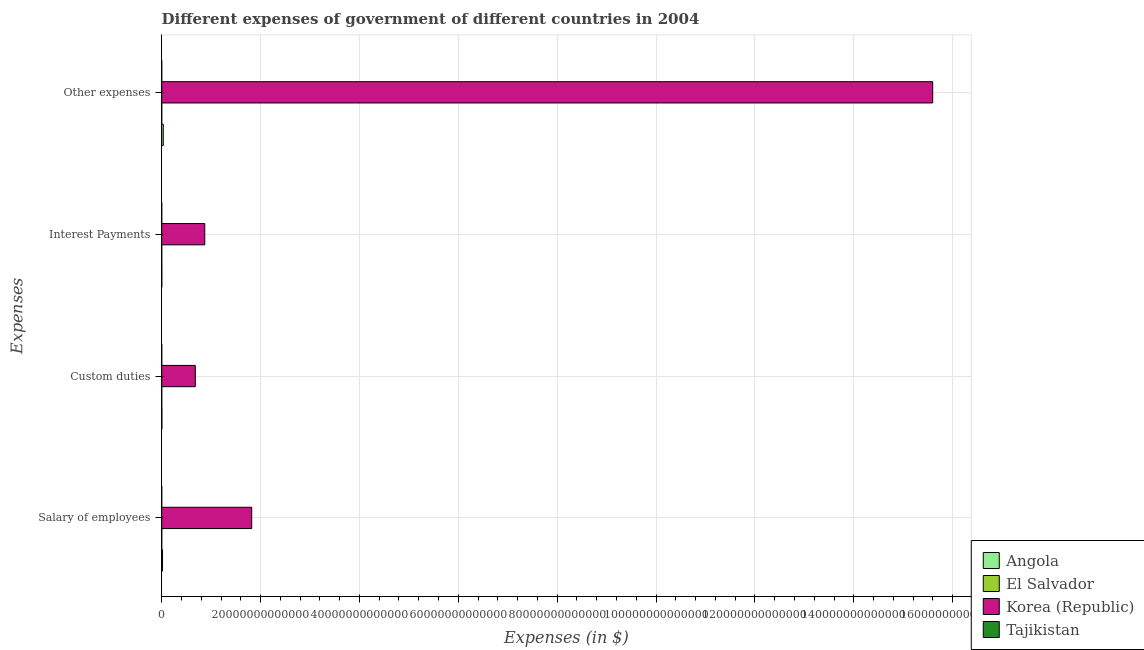How many groups of bars are there?
Keep it short and to the point. 4. Are the number of bars per tick equal to the number of legend labels?
Provide a short and direct response. Yes. How many bars are there on the 3rd tick from the bottom?
Offer a terse response. 4. What is the label of the 3rd group of bars from the top?
Offer a terse response. Custom duties. What is the amount spent on custom duties in Tajikistan?
Give a very brief answer. 9.66e+07. Across all countries, what is the maximum amount spent on salary of employees?
Your answer should be compact. 1.82e+13. Across all countries, what is the minimum amount spent on custom duties?
Make the answer very short. 9.66e+07. In which country was the amount spent on other expenses maximum?
Your response must be concise. Korea (Republic). In which country was the amount spent on custom duties minimum?
Keep it short and to the point. Tajikistan. What is the total amount spent on other expenses in the graph?
Keep it short and to the point. 1.56e+14. What is the difference between the amount spent on salary of employees in El Salvador and that in Korea (Republic)?
Provide a succinct answer. -1.82e+13. What is the difference between the amount spent on custom duties in Tajikistan and the amount spent on interest payments in Korea (Republic)?
Provide a short and direct response. -8.71e+12. What is the average amount spent on other expenses per country?
Offer a terse response. 3.91e+13. What is the difference between the amount spent on salary of employees and amount spent on interest payments in El Salvador?
Offer a terse response. 7.58e+08. What is the ratio of the amount spent on salary of employees in Tajikistan to that in Angola?
Ensure brevity in your answer.  0. Is the difference between the amount spent on interest payments in Angola and Korea (Republic) greater than the difference between the amount spent on salary of employees in Angola and Korea (Republic)?
Your answer should be compact. Yes. What is the difference between the highest and the second highest amount spent on salary of employees?
Provide a short and direct response. 1.80e+13. What is the difference between the highest and the lowest amount spent on salary of employees?
Give a very brief answer. 1.82e+13. Is it the case that in every country, the sum of the amount spent on interest payments and amount spent on custom duties is greater than the sum of amount spent on other expenses and amount spent on salary of employees?
Provide a succinct answer. No. What does the 3rd bar from the top in Interest Payments represents?
Make the answer very short. El Salvador. What does the 1st bar from the bottom in Salary of employees represents?
Your answer should be very brief. Angola. Are all the bars in the graph horizontal?
Give a very brief answer. Yes. What is the difference between two consecutive major ticks on the X-axis?
Your answer should be compact. 2.00e+13. Does the graph contain grids?
Offer a very short reply. Yes. Where does the legend appear in the graph?
Make the answer very short. Bottom right. How many legend labels are there?
Make the answer very short. 4. What is the title of the graph?
Ensure brevity in your answer.  Different expenses of government of different countries in 2004. What is the label or title of the X-axis?
Ensure brevity in your answer.  Expenses (in $). What is the label or title of the Y-axis?
Provide a succinct answer. Expenses. What is the Expenses (in $) in Angola in Salary of employees?
Ensure brevity in your answer.  1.67e+11. What is the Expenses (in $) in El Salvador in Salary of employees?
Provide a succinct answer. 1.12e+09. What is the Expenses (in $) of Korea (Republic) in Salary of employees?
Your answer should be very brief. 1.82e+13. What is the Expenses (in $) in Tajikistan in Salary of employees?
Keep it short and to the point. 7.91e+07. What is the Expenses (in $) in Angola in Custom duties?
Offer a very short reply. 2.48e+1. What is the Expenses (in $) in El Salvador in Custom duties?
Provide a succinct answer. 1.74e+08. What is the Expenses (in $) of Korea (Republic) in Custom duties?
Make the answer very short. 6.80e+12. What is the Expenses (in $) of Tajikistan in Custom duties?
Your answer should be compact. 9.66e+07. What is the Expenses (in $) in Angola in Interest Payments?
Provide a succinct answer. 1.78e+1. What is the Expenses (in $) in El Salvador in Interest Payments?
Give a very brief answer. 3.60e+08. What is the Expenses (in $) in Korea (Republic) in Interest Payments?
Your response must be concise. 8.71e+12. What is the Expenses (in $) of Tajikistan in Interest Payments?
Keep it short and to the point. 4.43e+07. What is the Expenses (in $) of Angola in Other expenses?
Provide a short and direct response. 3.18e+11. What is the Expenses (in $) of El Salvador in Other expenses?
Keep it short and to the point. 2.69e+09. What is the Expenses (in $) in Korea (Republic) in Other expenses?
Your response must be concise. 1.56e+14. What is the Expenses (in $) in Tajikistan in Other expenses?
Your response must be concise. 8.48e+08. Across all Expenses, what is the maximum Expenses (in $) in Angola?
Make the answer very short. 3.18e+11. Across all Expenses, what is the maximum Expenses (in $) of El Salvador?
Make the answer very short. 2.69e+09. Across all Expenses, what is the maximum Expenses (in $) of Korea (Republic)?
Your answer should be very brief. 1.56e+14. Across all Expenses, what is the maximum Expenses (in $) of Tajikistan?
Provide a succinct answer. 8.48e+08. Across all Expenses, what is the minimum Expenses (in $) of Angola?
Your response must be concise. 1.78e+1. Across all Expenses, what is the minimum Expenses (in $) of El Salvador?
Keep it short and to the point. 1.74e+08. Across all Expenses, what is the minimum Expenses (in $) in Korea (Republic)?
Keep it short and to the point. 6.80e+12. Across all Expenses, what is the minimum Expenses (in $) of Tajikistan?
Offer a terse response. 4.43e+07. What is the total Expenses (in $) in Angola in the graph?
Your answer should be compact. 5.27e+11. What is the total Expenses (in $) in El Salvador in the graph?
Offer a very short reply. 4.35e+09. What is the total Expenses (in $) of Korea (Republic) in the graph?
Your answer should be very brief. 1.90e+14. What is the total Expenses (in $) in Tajikistan in the graph?
Offer a very short reply. 1.07e+09. What is the difference between the Expenses (in $) of Angola in Salary of employees and that in Custom duties?
Provide a short and direct response. 1.42e+11. What is the difference between the Expenses (in $) of El Salvador in Salary of employees and that in Custom duties?
Give a very brief answer. 9.44e+08. What is the difference between the Expenses (in $) in Korea (Republic) in Salary of employees and that in Custom duties?
Offer a terse response. 1.14e+13. What is the difference between the Expenses (in $) in Tajikistan in Salary of employees and that in Custom duties?
Provide a short and direct response. -1.75e+07. What is the difference between the Expenses (in $) in Angola in Salary of employees and that in Interest Payments?
Keep it short and to the point. 1.49e+11. What is the difference between the Expenses (in $) of El Salvador in Salary of employees and that in Interest Payments?
Give a very brief answer. 7.58e+08. What is the difference between the Expenses (in $) of Korea (Republic) in Salary of employees and that in Interest Payments?
Your answer should be compact. 9.50e+12. What is the difference between the Expenses (in $) in Tajikistan in Salary of employees and that in Interest Payments?
Keep it short and to the point. 3.48e+07. What is the difference between the Expenses (in $) in Angola in Salary of employees and that in Other expenses?
Give a very brief answer. -1.51e+11. What is the difference between the Expenses (in $) in El Salvador in Salary of employees and that in Other expenses?
Provide a short and direct response. -1.57e+09. What is the difference between the Expenses (in $) in Korea (Republic) in Salary of employees and that in Other expenses?
Keep it short and to the point. -1.38e+14. What is the difference between the Expenses (in $) in Tajikistan in Salary of employees and that in Other expenses?
Make the answer very short. -7.69e+08. What is the difference between the Expenses (in $) in Angola in Custom duties and that in Interest Payments?
Ensure brevity in your answer.  7.04e+09. What is the difference between the Expenses (in $) of El Salvador in Custom duties and that in Interest Payments?
Your response must be concise. -1.86e+08. What is the difference between the Expenses (in $) in Korea (Republic) in Custom duties and that in Interest Payments?
Provide a short and direct response. -1.91e+12. What is the difference between the Expenses (in $) of Tajikistan in Custom duties and that in Interest Payments?
Ensure brevity in your answer.  5.23e+07. What is the difference between the Expenses (in $) of Angola in Custom duties and that in Other expenses?
Your response must be concise. -2.93e+11. What is the difference between the Expenses (in $) in El Salvador in Custom duties and that in Other expenses?
Offer a very short reply. -2.52e+09. What is the difference between the Expenses (in $) in Korea (Republic) in Custom duties and that in Other expenses?
Make the answer very short. -1.49e+14. What is the difference between the Expenses (in $) of Tajikistan in Custom duties and that in Other expenses?
Provide a short and direct response. -7.51e+08. What is the difference between the Expenses (in $) in Angola in Interest Payments and that in Other expenses?
Your answer should be very brief. -3.00e+11. What is the difference between the Expenses (in $) in El Salvador in Interest Payments and that in Other expenses?
Offer a terse response. -2.33e+09. What is the difference between the Expenses (in $) of Korea (Republic) in Interest Payments and that in Other expenses?
Keep it short and to the point. -1.47e+14. What is the difference between the Expenses (in $) of Tajikistan in Interest Payments and that in Other expenses?
Make the answer very short. -8.04e+08. What is the difference between the Expenses (in $) in Angola in Salary of employees and the Expenses (in $) in El Salvador in Custom duties?
Keep it short and to the point. 1.67e+11. What is the difference between the Expenses (in $) of Angola in Salary of employees and the Expenses (in $) of Korea (Republic) in Custom duties?
Provide a short and direct response. -6.63e+12. What is the difference between the Expenses (in $) of Angola in Salary of employees and the Expenses (in $) of Tajikistan in Custom duties?
Provide a succinct answer. 1.67e+11. What is the difference between the Expenses (in $) in El Salvador in Salary of employees and the Expenses (in $) in Korea (Republic) in Custom duties?
Your answer should be compact. -6.80e+12. What is the difference between the Expenses (in $) in El Salvador in Salary of employees and the Expenses (in $) in Tajikistan in Custom duties?
Your answer should be compact. 1.02e+09. What is the difference between the Expenses (in $) in Korea (Republic) in Salary of employees and the Expenses (in $) in Tajikistan in Custom duties?
Your answer should be compact. 1.82e+13. What is the difference between the Expenses (in $) of Angola in Salary of employees and the Expenses (in $) of El Salvador in Interest Payments?
Your answer should be compact. 1.67e+11. What is the difference between the Expenses (in $) of Angola in Salary of employees and the Expenses (in $) of Korea (Republic) in Interest Payments?
Keep it short and to the point. -8.54e+12. What is the difference between the Expenses (in $) in Angola in Salary of employees and the Expenses (in $) in Tajikistan in Interest Payments?
Your answer should be compact. 1.67e+11. What is the difference between the Expenses (in $) of El Salvador in Salary of employees and the Expenses (in $) of Korea (Republic) in Interest Payments?
Provide a succinct answer. -8.71e+12. What is the difference between the Expenses (in $) of El Salvador in Salary of employees and the Expenses (in $) of Tajikistan in Interest Payments?
Keep it short and to the point. 1.07e+09. What is the difference between the Expenses (in $) of Korea (Republic) in Salary of employees and the Expenses (in $) of Tajikistan in Interest Payments?
Your answer should be compact. 1.82e+13. What is the difference between the Expenses (in $) in Angola in Salary of employees and the Expenses (in $) in El Salvador in Other expenses?
Give a very brief answer. 1.64e+11. What is the difference between the Expenses (in $) of Angola in Salary of employees and the Expenses (in $) of Korea (Republic) in Other expenses?
Offer a terse response. -1.56e+14. What is the difference between the Expenses (in $) of Angola in Salary of employees and the Expenses (in $) of Tajikistan in Other expenses?
Ensure brevity in your answer.  1.66e+11. What is the difference between the Expenses (in $) of El Salvador in Salary of employees and the Expenses (in $) of Korea (Republic) in Other expenses?
Your answer should be compact. -1.56e+14. What is the difference between the Expenses (in $) in El Salvador in Salary of employees and the Expenses (in $) in Tajikistan in Other expenses?
Offer a terse response. 2.71e+08. What is the difference between the Expenses (in $) of Korea (Republic) in Salary of employees and the Expenses (in $) of Tajikistan in Other expenses?
Your answer should be very brief. 1.82e+13. What is the difference between the Expenses (in $) of Angola in Custom duties and the Expenses (in $) of El Salvador in Interest Payments?
Offer a terse response. 2.44e+1. What is the difference between the Expenses (in $) of Angola in Custom duties and the Expenses (in $) of Korea (Republic) in Interest Payments?
Make the answer very short. -8.69e+12. What is the difference between the Expenses (in $) in Angola in Custom duties and the Expenses (in $) in Tajikistan in Interest Payments?
Offer a terse response. 2.47e+1. What is the difference between the Expenses (in $) in El Salvador in Custom duties and the Expenses (in $) in Korea (Republic) in Interest Payments?
Your answer should be compact. -8.71e+12. What is the difference between the Expenses (in $) in El Salvador in Custom duties and the Expenses (in $) in Tajikistan in Interest Payments?
Provide a short and direct response. 1.30e+08. What is the difference between the Expenses (in $) of Korea (Republic) in Custom duties and the Expenses (in $) of Tajikistan in Interest Payments?
Give a very brief answer. 6.80e+12. What is the difference between the Expenses (in $) in Angola in Custom duties and the Expenses (in $) in El Salvador in Other expenses?
Give a very brief answer. 2.21e+1. What is the difference between the Expenses (in $) of Angola in Custom duties and the Expenses (in $) of Korea (Republic) in Other expenses?
Give a very brief answer. -1.56e+14. What is the difference between the Expenses (in $) of Angola in Custom duties and the Expenses (in $) of Tajikistan in Other expenses?
Offer a terse response. 2.39e+1. What is the difference between the Expenses (in $) in El Salvador in Custom duties and the Expenses (in $) in Korea (Republic) in Other expenses?
Your answer should be compact. -1.56e+14. What is the difference between the Expenses (in $) of El Salvador in Custom duties and the Expenses (in $) of Tajikistan in Other expenses?
Your answer should be compact. -6.73e+08. What is the difference between the Expenses (in $) of Korea (Republic) in Custom duties and the Expenses (in $) of Tajikistan in Other expenses?
Your answer should be very brief. 6.80e+12. What is the difference between the Expenses (in $) of Angola in Interest Payments and the Expenses (in $) of El Salvador in Other expenses?
Offer a terse response. 1.51e+1. What is the difference between the Expenses (in $) of Angola in Interest Payments and the Expenses (in $) of Korea (Republic) in Other expenses?
Your answer should be very brief. -1.56e+14. What is the difference between the Expenses (in $) of Angola in Interest Payments and the Expenses (in $) of Tajikistan in Other expenses?
Ensure brevity in your answer.  1.69e+1. What is the difference between the Expenses (in $) in El Salvador in Interest Payments and the Expenses (in $) in Korea (Republic) in Other expenses?
Ensure brevity in your answer.  -1.56e+14. What is the difference between the Expenses (in $) in El Salvador in Interest Payments and the Expenses (in $) in Tajikistan in Other expenses?
Ensure brevity in your answer.  -4.88e+08. What is the difference between the Expenses (in $) in Korea (Republic) in Interest Payments and the Expenses (in $) in Tajikistan in Other expenses?
Keep it short and to the point. 8.71e+12. What is the average Expenses (in $) of Angola per Expenses?
Offer a very short reply. 1.32e+11. What is the average Expenses (in $) of El Salvador per Expenses?
Keep it short and to the point. 1.09e+09. What is the average Expenses (in $) of Korea (Republic) per Expenses?
Offer a very short reply. 4.74e+13. What is the average Expenses (in $) in Tajikistan per Expenses?
Provide a succinct answer. 2.67e+08. What is the difference between the Expenses (in $) of Angola and Expenses (in $) of El Salvador in Salary of employees?
Your answer should be very brief. 1.66e+11. What is the difference between the Expenses (in $) in Angola and Expenses (in $) in Korea (Republic) in Salary of employees?
Your response must be concise. -1.80e+13. What is the difference between the Expenses (in $) of Angola and Expenses (in $) of Tajikistan in Salary of employees?
Make the answer very short. 1.67e+11. What is the difference between the Expenses (in $) of El Salvador and Expenses (in $) of Korea (Republic) in Salary of employees?
Ensure brevity in your answer.  -1.82e+13. What is the difference between the Expenses (in $) in El Salvador and Expenses (in $) in Tajikistan in Salary of employees?
Ensure brevity in your answer.  1.04e+09. What is the difference between the Expenses (in $) of Korea (Republic) and Expenses (in $) of Tajikistan in Salary of employees?
Offer a very short reply. 1.82e+13. What is the difference between the Expenses (in $) of Angola and Expenses (in $) of El Salvador in Custom duties?
Offer a very short reply. 2.46e+1. What is the difference between the Expenses (in $) of Angola and Expenses (in $) of Korea (Republic) in Custom duties?
Offer a very short reply. -6.77e+12. What is the difference between the Expenses (in $) of Angola and Expenses (in $) of Tajikistan in Custom duties?
Offer a very short reply. 2.47e+1. What is the difference between the Expenses (in $) of El Salvador and Expenses (in $) of Korea (Republic) in Custom duties?
Offer a very short reply. -6.80e+12. What is the difference between the Expenses (in $) of El Salvador and Expenses (in $) of Tajikistan in Custom duties?
Your answer should be compact. 7.78e+07. What is the difference between the Expenses (in $) in Korea (Republic) and Expenses (in $) in Tajikistan in Custom duties?
Keep it short and to the point. 6.80e+12. What is the difference between the Expenses (in $) of Angola and Expenses (in $) of El Salvador in Interest Payments?
Give a very brief answer. 1.74e+1. What is the difference between the Expenses (in $) in Angola and Expenses (in $) in Korea (Republic) in Interest Payments?
Your answer should be compact. -8.69e+12. What is the difference between the Expenses (in $) in Angola and Expenses (in $) in Tajikistan in Interest Payments?
Your answer should be compact. 1.77e+1. What is the difference between the Expenses (in $) of El Salvador and Expenses (in $) of Korea (Republic) in Interest Payments?
Make the answer very short. -8.71e+12. What is the difference between the Expenses (in $) of El Salvador and Expenses (in $) of Tajikistan in Interest Payments?
Make the answer very short. 3.16e+08. What is the difference between the Expenses (in $) in Korea (Republic) and Expenses (in $) in Tajikistan in Interest Payments?
Your answer should be compact. 8.71e+12. What is the difference between the Expenses (in $) in Angola and Expenses (in $) in El Salvador in Other expenses?
Make the answer very short. 3.15e+11. What is the difference between the Expenses (in $) in Angola and Expenses (in $) in Korea (Republic) in Other expenses?
Provide a succinct answer. -1.56e+14. What is the difference between the Expenses (in $) of Angola and Expenses (in $) of Tajikistan in Other expenses?
Offer a very short reply. 3.17e+11. What is the difference between the Expenses (in $) in El Salvador and Expenses (in $) in Korea (Republic) in Other expenses?
Keep it short and to the point. -1.56e+14. What is the difference between the Expenses (in $) of El Salvador and Expenses (in $) of Tajikistan in Other expenses?
Offer a terse response. 1.84e+09. What is the difference between the Expenses (in $) of Korea (Republic) and Expenses (in $) of Tajikistan in Other expenses?
Offer a very short reply. 1.56e+14. What is the ratio of the Expenses (in $) of Angola in Salary of employees to that in Custom duties?
Ensure brevity in your answer.  6.74. What is the ratio of the Expenses (in $) of El Salvador in Salary of employees to that in Custom duties?
Offer a terse response. 6.41. What is the ratio of the Expenses (in $) in Korea (Republic) in Salary of employees to that in Custom duties?
Offer a terse response. 2.68. What is the ratio of the Expenses (in $) in Tajikistan in Salary of employees to that in Custom duties?
Offer a very short reply. 0.82. What is the ratio of the Expenses (in $) of Angola in Salary of employees to that in Interest Payments?
Your answer should be very brief. 9.41. What is the ratio of the Expenses (in $) of El Salvador in Salary of employees to that in Interest Payments?
Provide a short and direct response. 3.11. What is the ratio of the Expenses (in $) in Korea (Republic) in Salary of employees to that in Interest Payments?
Give a very brief answer. 2.09. What is the ratio of the Expenses (in $) of Tajikistan in Salary of employees to that in Interest Payments?
Ensure brevity in your answer.  1.79. What is the ratio of the Expenses (in $) in Angola in Salary of employees to that in Other expenses?
Offer a very short reply. 0.53. What is the ratio of the Expenses (in $) of El Salvador in Salary of employees to that in Other expenses?
Provide a succinct answer. 0.42. What is the ratio of the Expenses (in $) of Korea (Republic) in Salary of employees to that in Other expenses?
Your response must be concise. 0.12. What is the ratio of the Expenses (in $) of Tajikistan in Salary of employees to that in Other expenses?
Offer a very short reply. 0.09. What is the ratio of the Expenses (in $) in Angola in Custom duties to that in Interest Payments?
Offer a very short reply. 1.4. What is the ratio of the Expenses (in $) in El Salvador in Custom duties to that in Interest Payments?
Provide a succinct answer. 0.48. What is the ratio of the Expenses (in $) of Korea (Republic) in Custom duties to that in Interest Payments?
Ensure brevity in your answer.  0.78. What is the ratio of the Expenses (in $) of Tajikistan in Custom duties to that in Interest Payments?
Your answer should be very brief. 2.18. What is the ratio of the Expenses (in $) of Angola in Custom duties to that in Other expenses?
Ensure brevity in your answer.  0.08. What is the ratio of the Expenses (in $) of El Salvador in Custom duties to that in Other expenses?
Your answer should be compact. 0.06. What is the ratio of the Expenses (in $) of Korea (Republic) in Custom duties to that in Other expenses?
Offer a terse response. 0.04. What is the ratio of the Expenses (in $) in Tajikistan in Custom duties to that in Other expenses?
Provide a succinct answer. 0.11. What is the ratio of the Expenses (in $) of Angola in Interest Payments to that in Other expenses?
Your answer should be compact. 0.06. What is the ratio of the Expenses (in $) of El Salvador in Interest Payments to that in Other expenses?
Offer a very short reply. 0.13. What is the ratio of the Expenses (in $) of Korea (Republic) in Interest Payments to that in Other expenses?
Offer a very short reply. 0.06. What is the ratio of the Expenses (in $) in Tajikistan in Interest Payments to that in Other expenses?
Offer a terse response. 0.05. What is the difference between the highest and the second highest Expenses (in $) in Angola?
Ensure brevity in your answer.  1.51e+11. What is the difference between the highest and the second highest Expenses (in $) in El Salvador?
Make the answer very short. 1.57e+09. What is the difference between the highest and the second highest Expenses (in $) of Korea (Republic)?
Offer a terse response. 1.38e+14. What is the difference between the highest and the second highest Expenses (in $) of Tajikistan?
Your answer should be very brief. 7.51e+08. What is the difference between the highest and the lowest Expenses (in $) in Angola?
Your answer should be very brief. 3.00e+11. What is the difference between the highest and the lowest Expenses (in $) in El Salvador?
Your answer should be compact. 2.52e+09. What is the difference between the highest and the lowest Expenses (in $) in Korea (Republic)?
Your answer should be compact. 1.49e+14. What is the difference between the highest and the lowest Expenses (in $) of Tajikistan?
Offer a very short reply. 8.04e+08. 